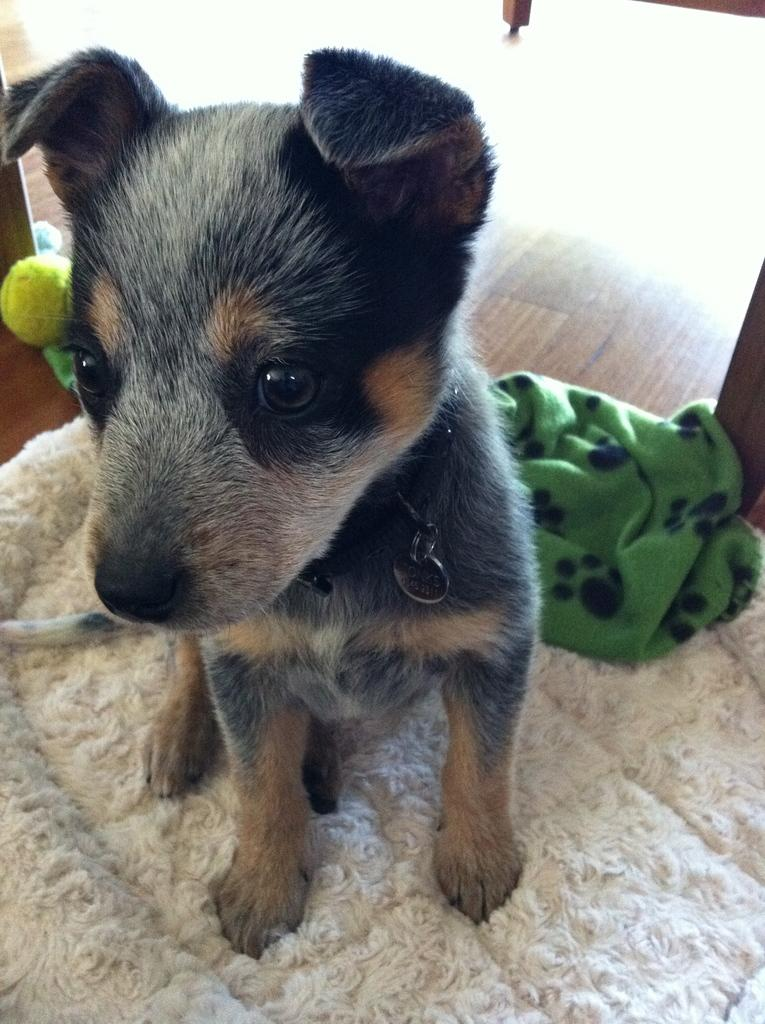What is the main subject in the center of the image? There is a dog in the center of the image. What is the dog positioned on? The dog is on a mat. What can be seen in the background of the image? There is cloth and a ball visible in the background of the image. What type of surface is visible in the background of the image? There is a floor visible in the background of the image. What type of pie is being served on the floor in the image? There is no pie present in the image; it features a dog on a mat with a ball and cloth visible in the background. 